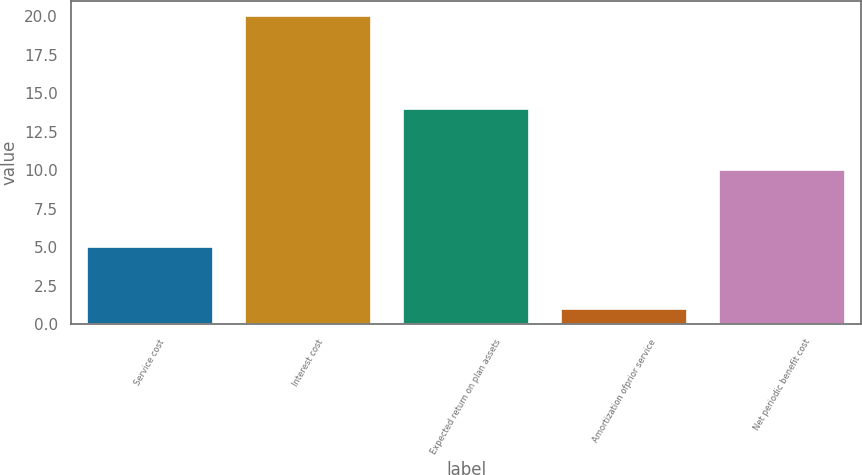<chart> <loc_0><loc_0><loc_500><loc_500><bar_chart><fcel>Service cost<fcel>Interest cost<fcel>Expected return on plan assets<fcel>Amortization ofprior service<fcel>Net periodic benefit cost<nl><fcel>5<fcel>20<fcel>14<fcel>1<fcel>10<nl></chart> 